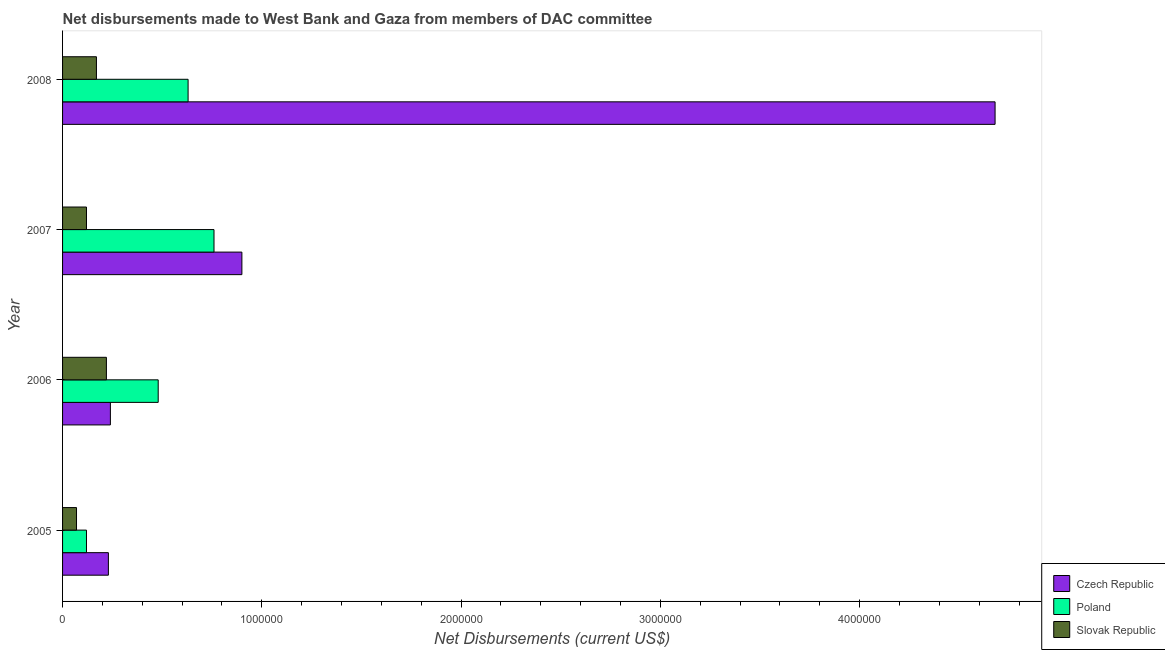Are the number of bars on each tick of the Y-axis equal?
Your answer should be very brief. Yes. What is the label of the 1st group of bars from the top?
Make the answer very short. 2008. What is the net disbursements made by slovak republic in 2007?
Give a very brief answer. 1.20e+05. Across all years, what is the maximum net disbursements made by poland?
Your answer should be compact. 7.60e+05. Across all years, what is the minimum net disbursements made by poland?
Your answer should be compact. 1.20e+05. In which year was the net disbursements made by poland maximum?
Provide a succinct answer. 2007. What is the total net disbursements made by czech republic in the graph?
Provide a short and direct response. 6.05e+06. What is the difference between the net disbursements made by slovak republic in 2005 and that in 2007?
Give a very brief answer. -5.00e+04. What is the difference between the net disbursements made by slovak republic in 2007 and the net disbursements made by czech republic in 2008?
Provide a short and direct response. -4.56e+06. What is the average net disbursements made by czech republic per year?
Your answer should be very brief. 1.51e+06. In the year 2006, what is the difference between the net disbursements made by czech republic and net disbursements made by slovak republic?
Your answer should be compact. 2.00e+04. What is the ratio of the net disbursements made by slovak republic in 2007 to that in 2008?
Make the answer very short. 0.71. What is the difference between the highest and the second highest net disbursements made by slovak republic?
Your response must be concise. 5.00e+04. What is the difference between the highest and the lowest net disbursements made by poland?
Keep it short and to the point. 6.40e+05. What does the 1st bar from the top in 2005 represents?
Offer a very short reply. Slovak Republic. Is it the case that in every year, the sum of the net disbursements made by czech republic and net disbursements made by poland is greater than the net disbursements made by slovak republic?
Make the answer very short. Yes. Are all the bars in the graph horizontal?
Make the answer very short. Yes. How many years are there in the graph?
Give a very brief answer. 4. What is the title of the graph?
Ensure brevity in your answer.  Net disbursements made to West Bank and Gaza from members of DAC committee. Does "Ages 65 and above" appear as one of the legend labels in the graph?
Keep it short and to the point. No. What is the label or title of the X-axis?
Make the answer very short. Net Disbursements (current US$). What is the Net Disbursements (current US$) in Poland in 2005?
Ensure brevity in your answer.  1.20e+05. What is the Net Disbursements (current US$) of Slovak Republic in 2005?
Your answer should be very brief. 7.00e+04. What is the Net Disbursements (current US$) in Czech Republic in 2006?
Your answer should be very brief. 2.40e+05. What is the Net Disbursements (current US$) in Poland in 2006?
Your answer should be very brief. 4.80e+05. What is the Net Disbursements (current US$) in Slovak Republic in 2006?
Your answer should be very brief. 2.20e+05. What is the Net Disbursements (current US$) in Poland in 2007?
Keep it short and to the point. 7.60e+05. What is the Net Disbursements (current US$) in Czech Republic in 2008?
Your answer should be very brief. 4.68e+06. What is the Net Disbursements (current US$) in Poland in 2008?
Your answer should be very brief. 6.30e+05. Across all years, what is the maximum Net Disbursements (current US$) in Czech Republic?
Offer a very short reply. 4.68e+06. Across all years, what is the maximum Net Disbursements (current US$) of Poland?
Your answer should be compact. 7.60e+05. Across all years, what is the maximum Net Disbursements (current US$) of Slovak Republic?
Your answer should be very brief. 2.20e+05. Across all years, what is the minimum Net Disbursements (current US$) in Czech Republic?
Ensure brevity in your answer.  2.30e+05. Across all years, what is the minimum Net Disbursements (current US$) in Slovak Republic?
Offer a terse response. 7.00e+04. What is the total Net Disbursements (current US$) of Czech Republic in the graph?
Offer a terse response. 6.05e+06. What is the total Net Disbursements (current US$) in Poland in the graph?
Provide a short and direct response. 1.99e+06. What is the total Net Disbursements (current US$) of Slovak Republic in the graph?
Your answer should be compact. 5.80e+05. What is the difference between the Net Disbursements (current US$) of Czech Republic in 2005 and that in 2006?
Offer a very short reply. -10000. What is the difference between the Net Disbursements (current US$) in Poland in 2005 and that in 2006?
Ensure brevity in your answer.  -3.60e+05. What is the difference between the Net Disbursements (current US$) of Czech Republic in 2005 and that in 2007?
Offer a very short reply. -6.70e+05. What is the difference between the Net Disbursements (current US$) of Poland in 2005 and that in 2007?
Provide a succinct answer. -6.40e+05. What is the difference between the Net Disbursements (current US$) of Czech Republic in 2005 and that in 2008?
Your answer should be very brief. -4.45e+06. What is the difference between the Net Disbursements (current US$) of Poland in 2005 and that in 2008?
Keep it short and to the point. -5.10e+05. What is the difference between the Net Disbursements (current US$) of Slovak Republic in 2005 and that in 2008?
Provide a succinct answer. -1.00e+05. What is the difference between the Net Disbursements (current US$) of Czech Republic in 2006 and that in 2007?
Ensure brevity in your answer.  -6.60e+05. What is the difference between the Net Disbursements (current US$) of Poland in 2006 and that in 2007?
Make the answer very short. -2.80e+05. What is the difference between the Net Disbursements (current US$) of Slovak Republic in 2006 and that in 2007?
Offer a very short reply. 1.00e+05. What is the difference between the Net Disbursements (current US$) of Czech Republic in 2006 and that in 2008?
Offer a terse response. -4.44e+06. What is the difference between the Net Disbursements (current US$) in Poland in 2006 and that in 2008?
Offer a terse response. -1.50e+05. What is the difference between the Net Disbursements (current US$) in Slovak Republic in 2006 and that in 2008?
Provide a short and direct response. 5.00e+04. What is the difference between the Net Disbursements (current US$) in Czech Republic in 2007 and that in 2008?
Your answer should be compact. -3.78e+06. What is the difference between the Net Disbursements (current US$) in Slovak Republic in 2007 and that in 2008?
Offer a terse response. -5.00e+04. What is the difference between the Net Disbursements (current US$) in Czech Republic in 2005 and the Net Disbursements (current US$) in Poland in 2007?
Offer a very short reply. -5.30e+05. What is the difference between the Net Disbursements (current US$) of Czech Republic in 2005 and the Net Disbursements (current US$) of Slovak Republic in 2007?
Your answer should be very brief. 1.10e+05. What is the difference between the Net Disbursements (current US$) of Poland in 2005 and the Net Disbursements (current US$) of Slovak Republic in 2007?
Your answer should be very brief. 0. What is the difference between the Net Disbursements (current US$) in Czech Republic in 2005 and the Net Disbursements (current US$) in Poland in 2008?
Make the answer very short. -4.00e+05. What is the difference between the Net Disbursements (current US$) of Czech Republic in 2005 and the Net Disbursements (current US$) of Slovak Republic in 2008?
Make the answer very short. 6.00e+04. What is the difference between the Net Disbursements (current US$) in Poland in 2005 and the Net Disbursements (current US$) in Slovak Republic in 2008?
Provide a succinct answer. -5.00e+04. What is the difference between the Net Disbursements (current US$) of Czech Republic in 2006 and the Net Disbursements (current US$) of Poland in 2007?
Keep it short and to the point. -5.20e+05. What is the difference between the Net Disbursements (current US$) of Czech Republic in 2006 and the Net Disbursements (current US$) of Slovak Republic in 2007?
Ensure brevity in your answer.  1.20e+05. What is the difference between the Net Disbursements (current US$) of Czech Republic in 2006 and the Net Disbursements (current US$) of Poland in 2008?
Your response must be concise. -3.90e+05. What is the difference between the Net Disbursements (current US$) of Czech Republic in 2006 and the Net Disbursements (current US$) of Slovak Republic in 2008?
Ensure brevity in your answer.  7.00e+04. What is the difference between the Net Disbursements (current US$) in Poland in 2006 and the Net Disbursements (current US$) in Slovak Republic in 2008?
Provide a succinct answer. 3.10e+05. What is the difference between the Net Disbursements (current US$) in Czech Republic in 2007 and the Net Disbursements (current US$) in Poland in 2008?
Provide a short and direct response. 2.70e+05. What is the difference between the Net Disbursements (current US$) of Czech Republic in 2007 and the Net Disbursements (current US$) of Slovak Republic in 2008?
Your answer should be very brief. 7.30e+05. What is the difference between the Net Disbursements (current US$) in Poland in 2007 and the Net Disbursements (current US$) in Slovak Republic in 2008?
Ensure brevity in your answer.  5.90e+05. What is the average Net Disbursements (current US$) in Czech Republic per year?
Provide a succinct answer. 1.51e+06. What is the average Net Disbursements (current US$) in Poland per year?
Offer a terse response. 4.98e+05. What is the average Net Disbursements (current US$) of Slovak Republic per year?
Provide a short and direct response. 1.45e+05. In the year 2005, what is the difference between the Net Disbursements (current US$) of Czech Republic and Net Disbursements (current US$) of Poland?
Make the answer very short. 1.10e+05. In the year 2005, what is the difference between the Net Disbursements (current US$) of Czech Republic and Net Disbursements (current US$) of Slovak Republic?
Give a very brief answer. 1.60e+05. In the year 2006, what is the difference between the Net Disbursements (current US$) of Czech Republic and Net Disbursements (current US$) of Poland?
Make the answer very short. -2.40e+05. In the year 2006, what is the difference between the Net Disbursements (current US$) of Poland and Net Disbursements (current US$) of Slovak Republic?
Keep it short and to the point. 2.60e+05. In the year 2007, what is the difference between the Net Disbursements (current US$) of Czech Republic and Net Disbursements (current US$) of Poland?
Make the answer very short. 1.40e+05. In the year 2007, what is the difference between the Net Disbursements (current US$) in Czech Republic and Net Disbursements (current US$) in Slovak Republic?
Make the answer very short. 7.80e+05. In the year 2007, what is the difference between the Net Disbursements (current US$) in Poland and Net Disbursements (current US$) in Slovak Republic?
Offer a very short reply. 6.40e+05. In the year 2008, what is the difference between the Net Disbursements (current US$) of Czech Republic and Net Disbursements (current US$) of Poland?
Provide a short and direct response. 4.05e+06. In the year 2008, what is the difference between the Net Disbursements (current US$) of Czech Republic and Net Disbursements (current US$) of Slovak Republic?
Ensure brevity in your answer.  4.51e+06. What is the ratio of the Net Disbursements (current US$) of Czech Republic in 2005 to that in 2006?
Offer a terse response. 0.96. What is the ratio of the Net Disbursements (current US$) in Slovak Republic in 2005 to that in 2006?
Your response must be concise. 0.32. What is the ratio of the Net Disbursements (current US$) in Czech Republic in 2005 to that in 2007?
Give a very brief answer. 0.26. What is the ratio of the Net Disbursements (current US$) in Poland in 2005 to that in 2007?
Your response must be concise. 0.16. What is the ratio of the Net Disbursements (current US$) in Slovak Republic in 2005 to that in 2007?
Give a very brief answer. 0.58. What is the ratio of the Net Disbursements (current US$) of Czech Republic in 2005 to that in 2008?
Make the answer very short. 0.05. What is the ratio of the Net Disbursements (current US$) in Poland in 2005 to that in 2008?
Make the answer very short. 0.19. What is the ratio of the Net Disbursements (current US$) in Slovak Republic in 2005 to that in 2008?
Provide a short and direct response. 0.41. What is the ratio of the Net Disbursements (current US$) in Czech Republic in 2006 to that in 2007?
Give a very brief answer. 0.27. What is the ratio of the Net Disbursements (current US$) of Poland in 2006 to that in 2007?
Keep it short and to the point. 0.63. What is the ratio of the Net Disbursements (current US$) in Slovak Republic in 2006 to that in 2007?
Offer a very short reply. 1.83. What is the ratio of the Net Disbursements (current US$) in Czech Republic in 2006 to that in 2008?
Provide a short and direct response. 0.05. What is the ratio of the Net Disbursements (current US$) of Poland in 2006 to that in 2008?
Give a very brief answer. 0.76. What is the ratio of the Net Disbursements (current US$) in Slovak Republic in 2006 to that in 2008?
Offer a terse response. 1.29. What is the ratio of the Net Disbursements (current US$) of Czech Republic in 2007 to that in 2008?
Make the answer very short. 0.19. What is the ratio of the Net Disbursements (current US$) in Poland in 2007 to that in 2008?
Offer a very short reply. 1.21. What is the ratio of the Net Disbursements (current US$) in Slovak Republic in 2007 to that in 2008?
Make the answer very short. 0.71. What is the difference between the highest and the second highest Net Disbursements (current US$) in Czech Republic?
Offer a terse response. 3.78e+06. What is the difference between the highest and the second highest Net Disbursements (current US$) of Poland?
Keep it short and to the point. 1.30e+05. What is the difference between the highest and the second highest Net Disbursements (current US$) of Slovak Republic?
Ensure brevity in your answer.  5.00e+04. What is the difference between the highest and the lowest Net Disbursements (current US$) of Czech Republic?
Your answer should be very brief. 4.45e+06. What is the difference between the highest and the lowest Net Disbursements (current US$) in Poland?
Give a very brief answer. 6.40e+05. What is the difference between the highest and the lowest Net Disbursements (current US$) in Slovak Republic?
Ensure brevity in your answer.  1.50e+05. 